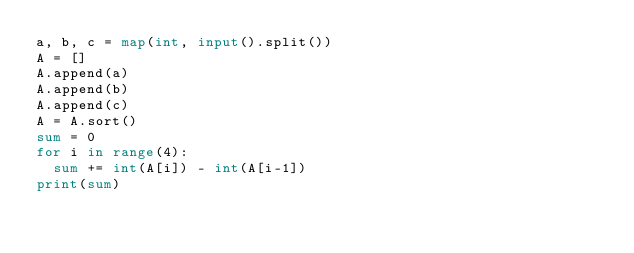<code> <loc_0><loc_0><loc_500><loc_500><_Python_>a, b, c = map(int, input().split())
A = []
A.append(a)
A.append(b)
A.append(c)
A = A.sort()
sum = 0
for i in range(4):
	sum += int(A[i]) - int(A[i-1])
print(sum)</code> 